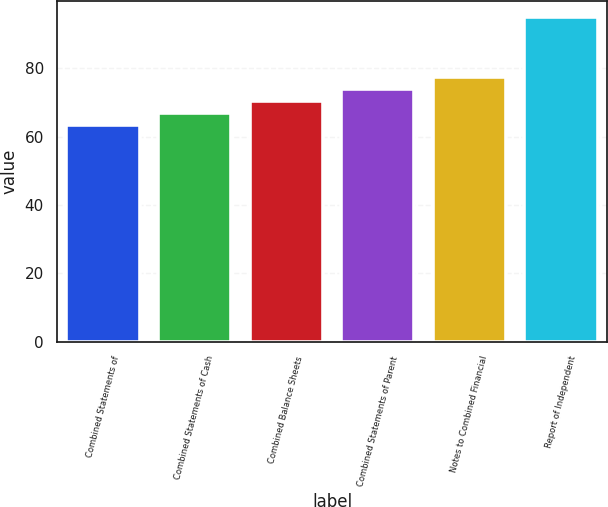<chart> <loc_0><loc_0><loc_500><loc_500><bar_chart><fcel>Combined Statements of<fcel>Combined Statements of Cash<fcel>Combined Balance Sheets<fcel>Combined Statements of Parent<fcel>Notes to Combined Financial<fcel>Report of Independent<nl><fcel>63.5<fcel>67<fcel>70.5<fcel>74<fcel>77.5<fcel>95<nl></chart> 